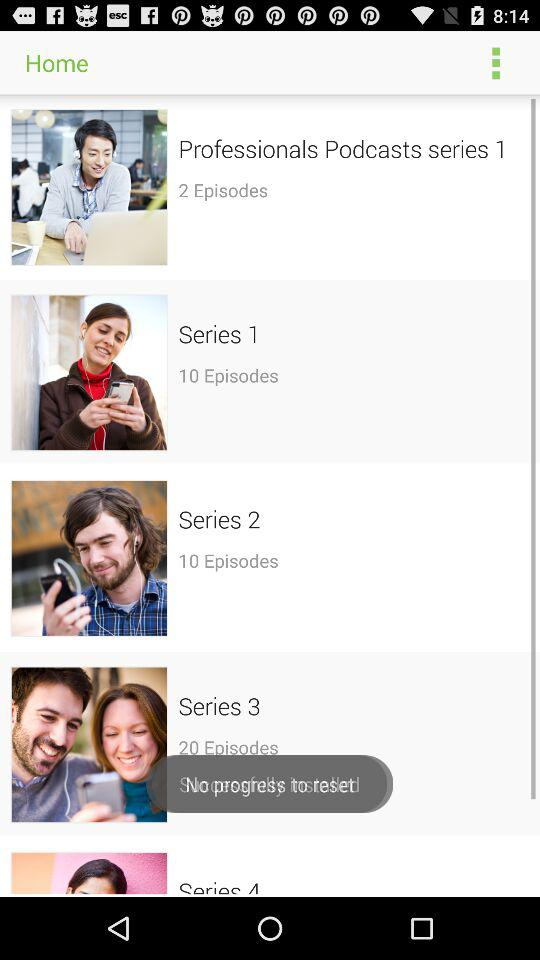How many episodes are in series 1 and 2 combined?
Answer the question using a single word or phrase. 20 